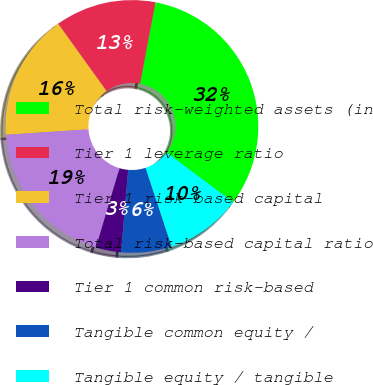<chart> <loc_0><loc_0><loc_500><loc_500><pie_chart><fcel>Total risk-weighted assets (in<fcel>Tier 1 leverage ratio<fcel>Tier 1 risk-based capital<fcel>Total risk-based capital ratio<fcel>Tier 1 common risk-based<fcel>Tangible common equity /<fcel>Tangible equity / tangible<nl><fcel>32.25%<fcel>12.9%<fcel>16.13%<fcel>19.35%<fcel>3.23%<fcel>6.45%<fcel>9.68%<nl></chart> 